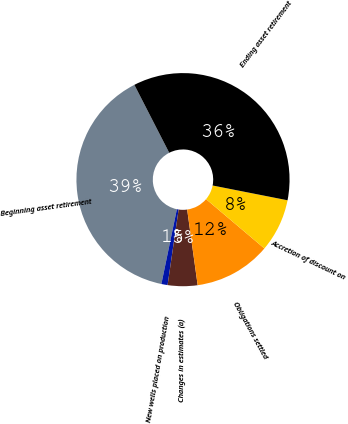Convert chart. <chart><loc_0><loc_0><loc_500><loc_500><pie_chart><fcel>Beginning asset retirement<fcel>New wells placed on production<fcel>Changes in estimates (a)<fcel>Obligations settled<fcel>Accretion of discount on<fcel>Ending asset retirement<nl><fcel>39.2%<fcel>0.94%<fcel>4.51%<fcel>11.63%<fcel>8.07%<fcel>35.64%<nl></chart> 